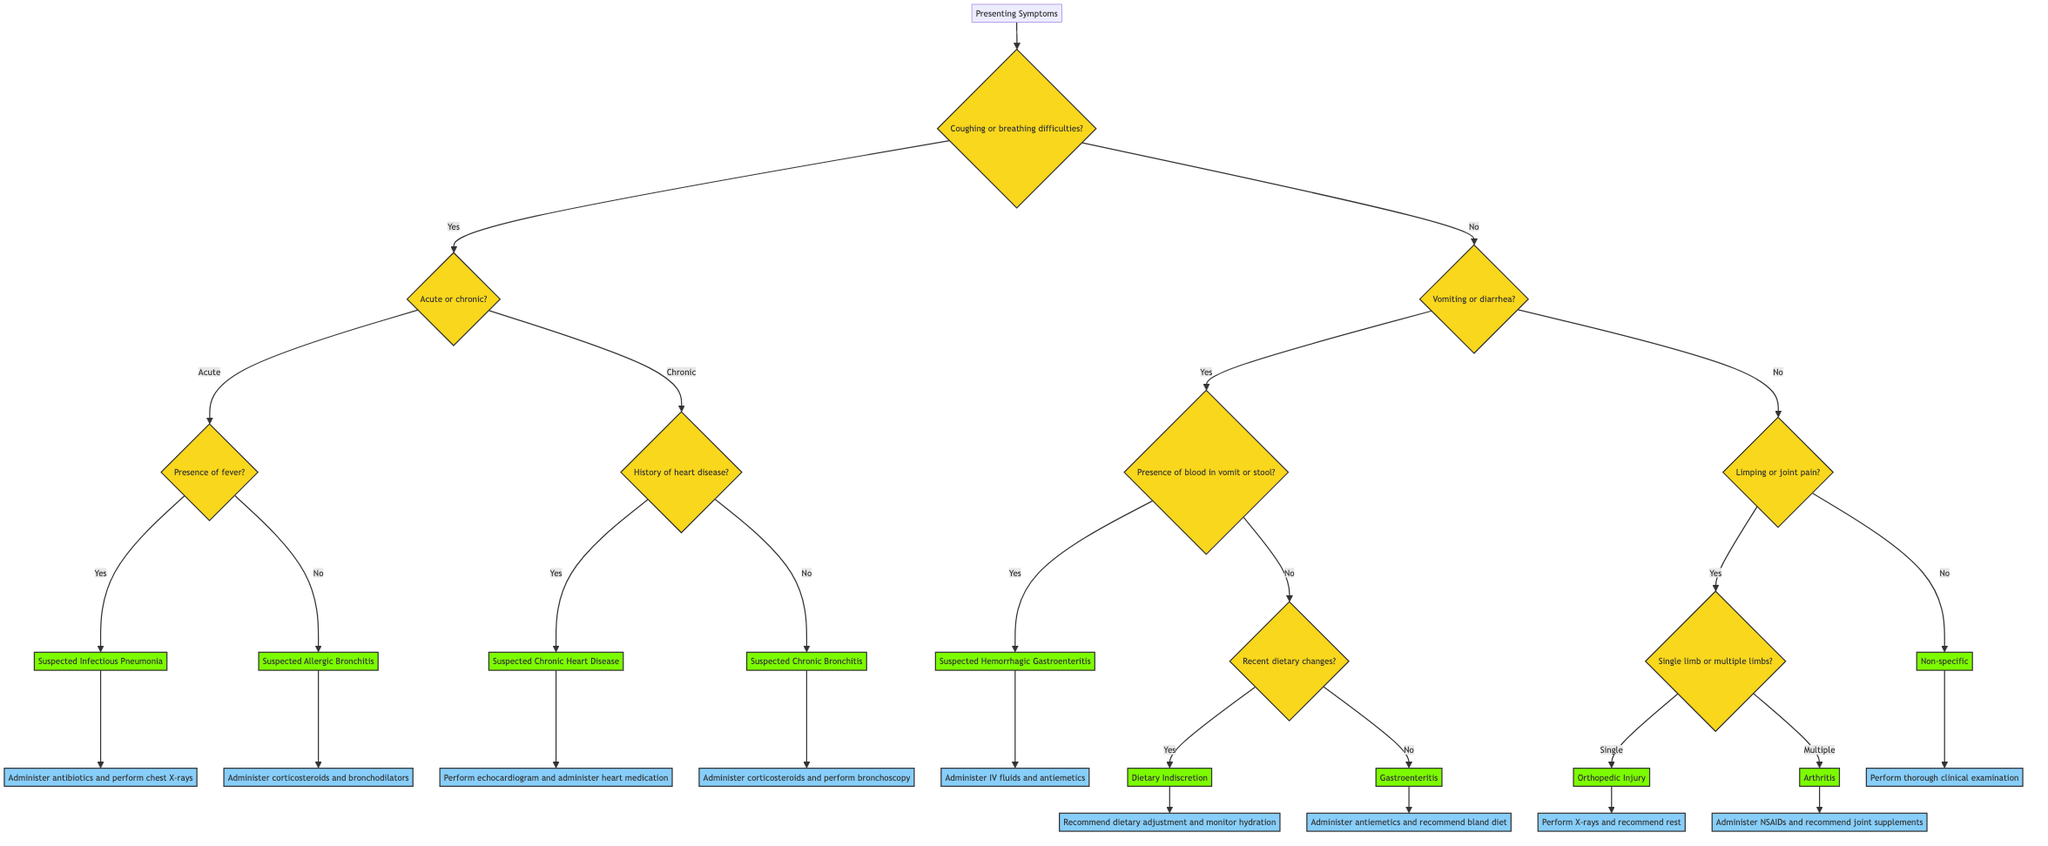What is the starting question in the decision tree? The decision tree begins with the question "Coughing or breathing difficulties?" This is the first decision point that leads to different branches based on the patient's symptoms.
Answer: Coughing or breathing difficulties? How many main symptoms are considered in the decision tree? There are three main symptoms branches in the decision tree: coughing or breathing difficulties, vomiting or diarrhea, and limping or joint pain. Each branch leads to further questions or diagnoses based on the symptoms presented.
Answer: Three What should be administered for suspected infectious pneumonia? For suspected infectious pneumonia, the protocol is to "Administer antibiotics and perform chest X-rays." This is the recommended action based on the diagnosis from the decision tree.
Answer: Administer antibiotics and perform chest X-rays What is the next step if there is limping or joint pain? If there is limping or joint pain, the next question to assess is "Single limb or multiple limbs?" This question leads to a distinction between potential diagnoses based on the observed symptoms.
Answer: Single limb or multiple limbs? What protocol is recommended for suspected hemorrhagic gastroenteritis? The protocol for suspected hemorrhagic gastroenteritis is to "Administer IV fluids and antiemetics." This is the specific action based on the diagnosis found in the decision tree.
Answer: Administer IV fluids and antiemetics If the dog has recently changed its diet, what is the likely diagnosis? If there have been recent dietary changes and no blood is present in the vomit or stool, the likely diagnosis according to the tree is "Dietary Indiscretion." This conclusion is based on the flow of the decision tree after assessing the related symptoms.
Answer: Dietary Indiscretion What happens after identifying suspected chronic heart disease? Upon identifying suspected chronic heart disease, the next step is to "Perform echocardiogram and administer heart medication." This outlines the necessary medical intervention based on the diagnosis.
Answer: Perform echocardiogram and administer heart medication If a dog is diagnosed with arthritis, what is the suggested protocol? The suggested protocol for a dog diagnosed with arthritis is to "Administer NSAIDs and recommend joint supplements." This protocol is directly derived from the decision tree’s flow regarding this diagnosis.
Answer: Administer NSAIDs and recommend joint supplements 